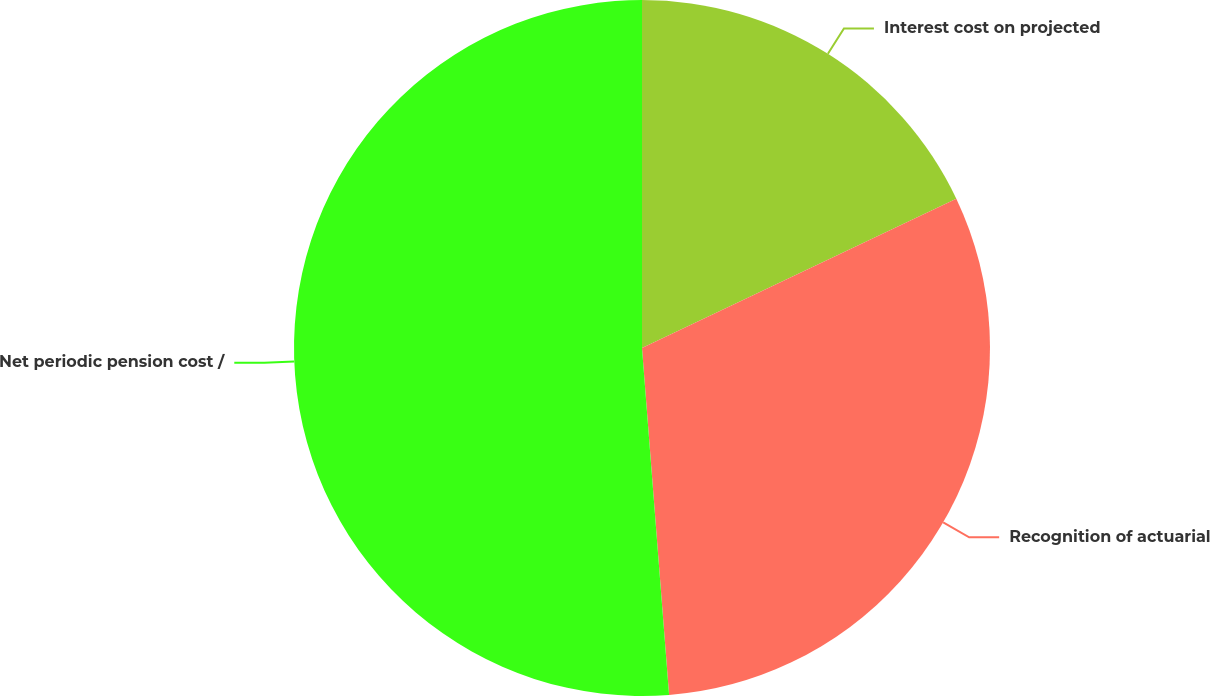<chart> <loc_0><loc_0><loc_500><loc_500><pie_chart><fcel>Interest cost on projected<fcel>Recognition of actuarial<fcel>Net periodic pension cost /<nl><fcel>17.94%<fcel>30.82%<fcel>51.24%<nl></chart> 